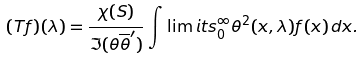Convert formula to latex. <formula><loc_0><loc_0><loc_500><loc_500>( T f ) ( \lambda ) = \frac { \chi ( S ) } { \Im ( \theta \overline { \theta } ^ { \prime } ) } \int \lim i t s _ { 0 } ^ { \infty } \theta ^ { 2 } ( x , \lambda ) f ( x ) \, d x .</formula> 